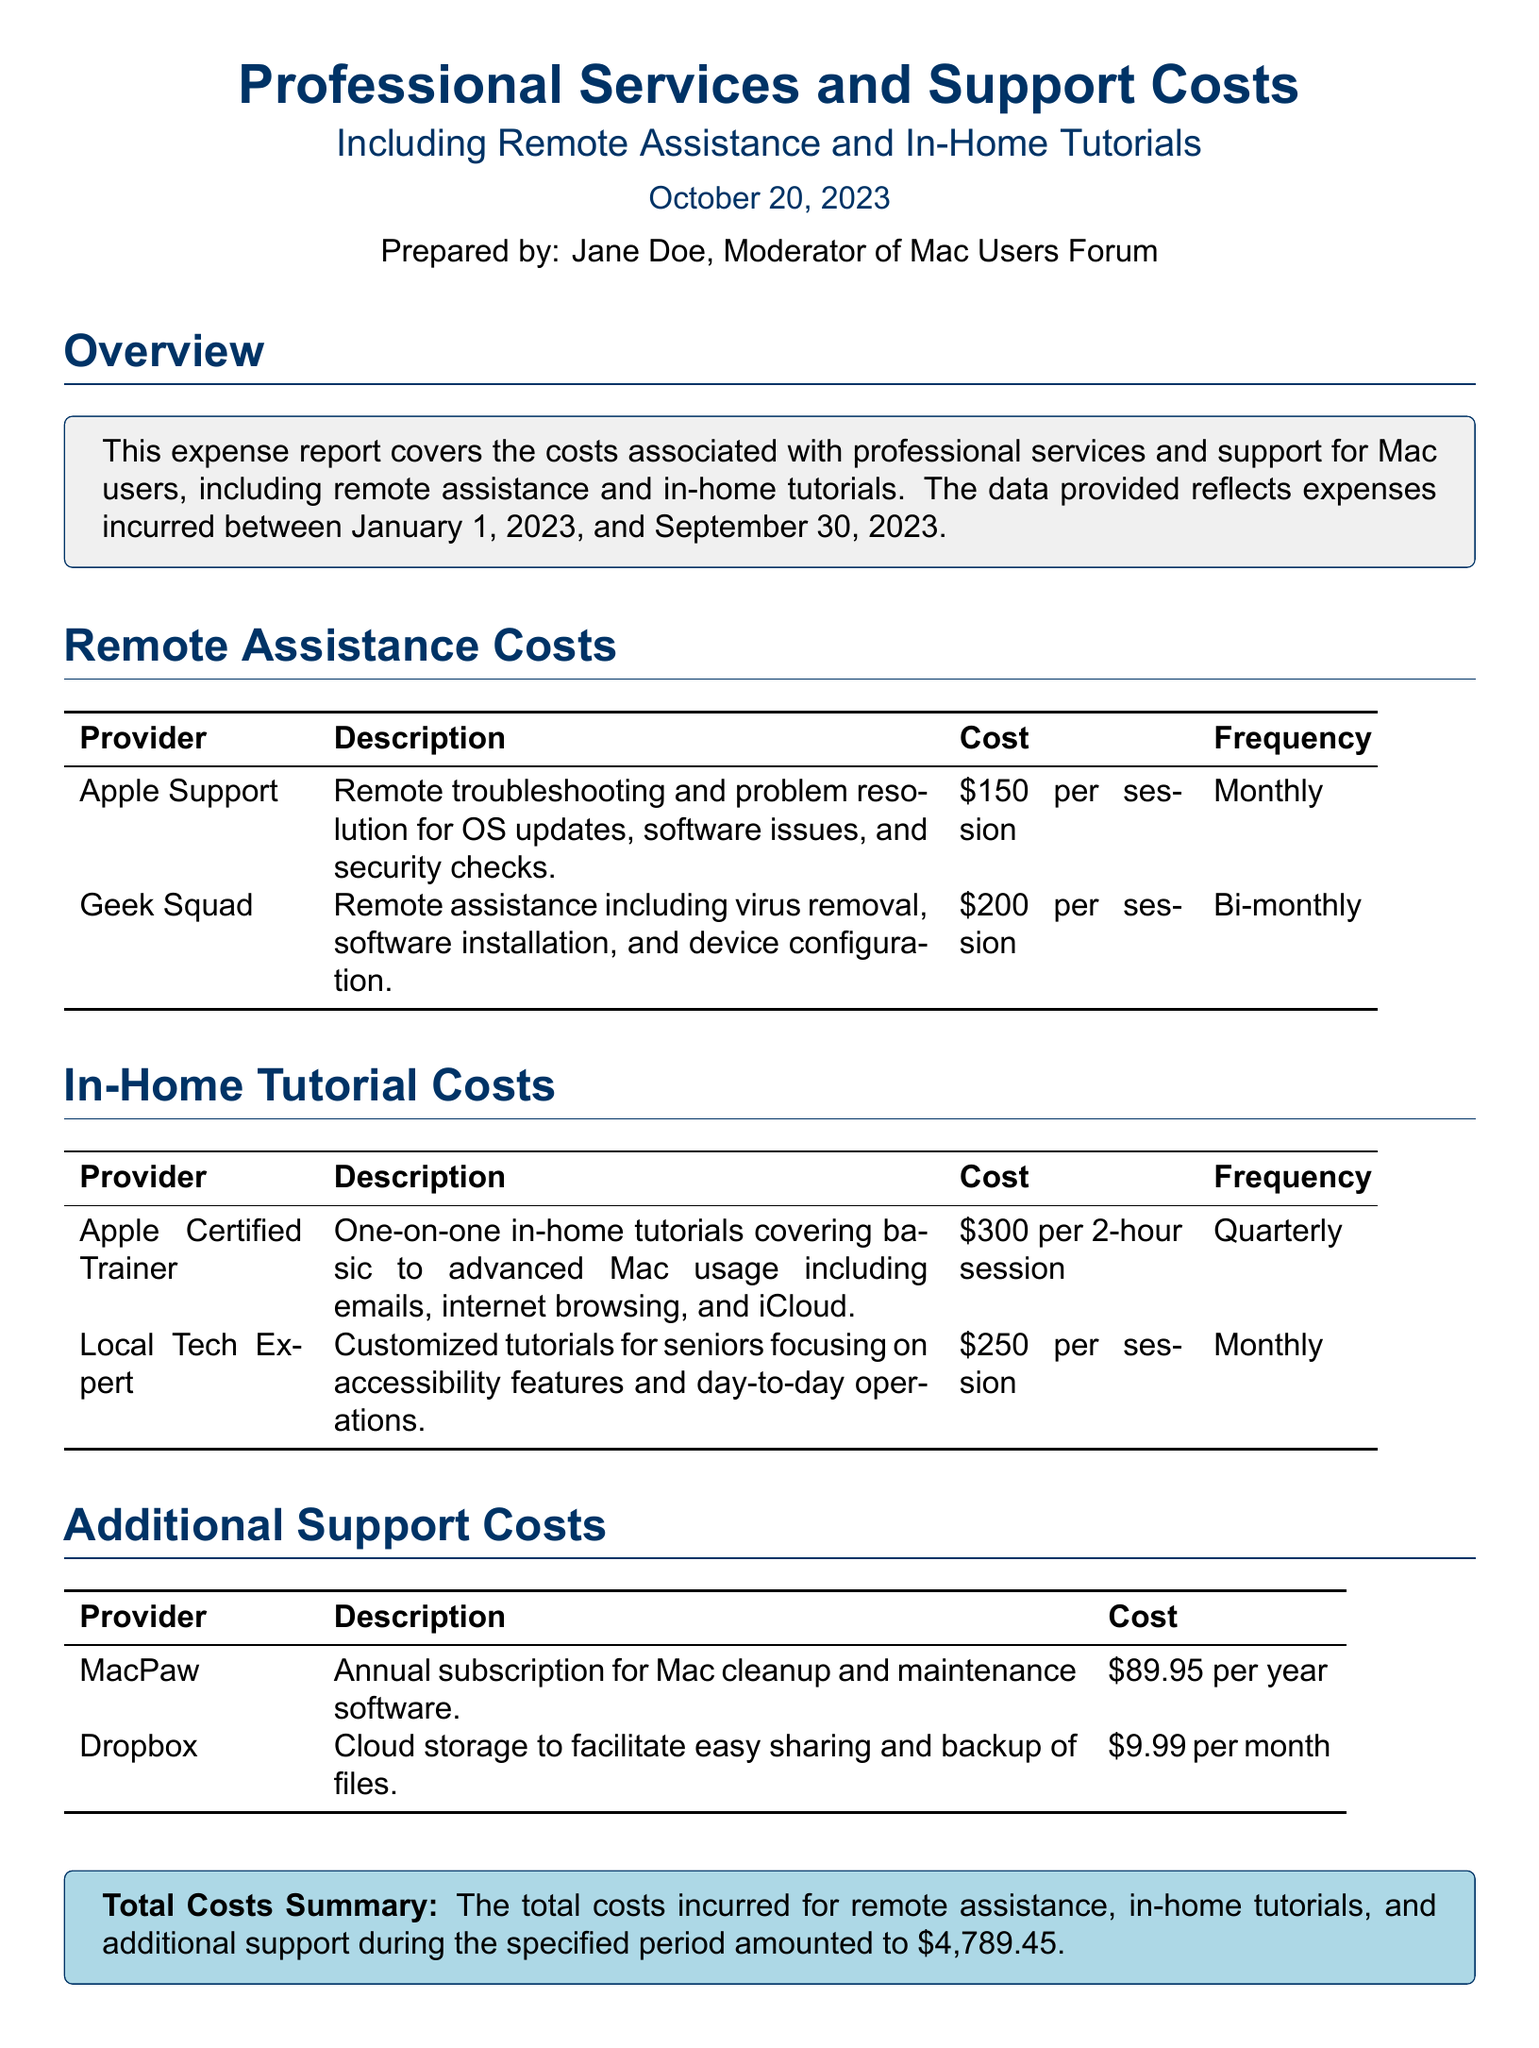What is the report about? The report covers costs associated with professional services and support for Mac users, including remote assistance and in-home tutorials.
Answer: Professional Services and Support Costs Who prepared the report? The report indicates that Jane Doe is the person who prepared it.
Answer: Jane Doe What is the cost of remote assistance from Apple Support? The specific cost for remote assistance from Apple Support is listed in the table.
Answer: 150 per session How often is Geek Squad's remote assistance provided? The frequency of Geek Squad's remote assistance sessions is mentioned under the frequency column.
Answer: Bi-monthly What is the cost of a 2-hour in-home tutorial with an Apple Certified Trainer? The table lists the cost for a session with an Apple Certified Trainer.
Answer: 300 per 2-hour session Who provides customized tutorials for seniors? The document mentions a specific provider focused on customized tutorials.
Answer: Local Tech Expert What is the annual cost for MacPaw's software? The document specifies the annual subscription cost for MacPaw's software.
Answer: 89.95 per year What is the total costs summary amount? The total costs incurred is summarized towards the end of the report.
Answer: 4,789.45 